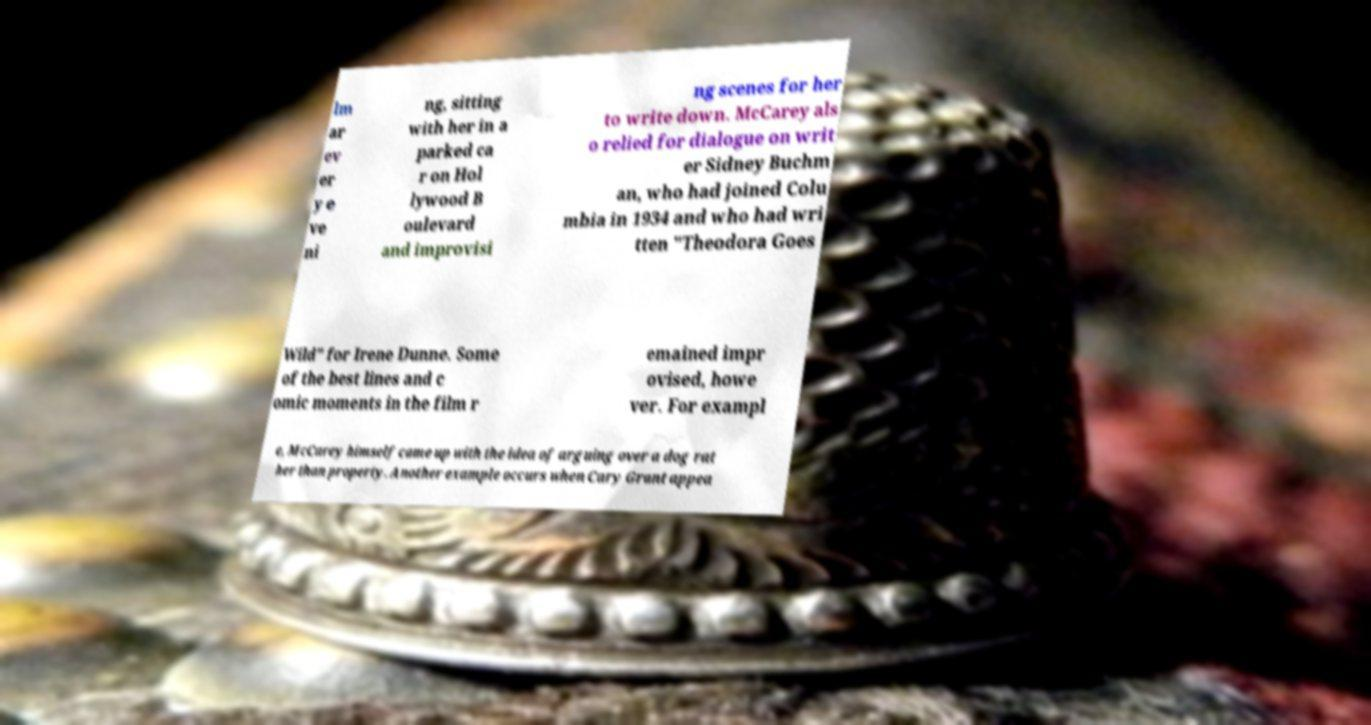I need the written content from this picture converted into text. Can you do that? lm ar ev er y e ve ni ng, sitting with her in a parked ca r on Hol lywood B oulevard and improvisi ng scenes for her to write down. McCarey als o relied for dialogue on writ er Sidney Buchm an, who had joined Colu mbia in 1934 and who had wri tten "Theodora Goes Wild" for Irene Dunne. Some of the best lines and c omic moments in the film r emained impr ovised, howe ver. For exampl e, McCarey himself came up with the idea of arguing over a dog rat her than property. Another example occurs when Cary Grant appea 